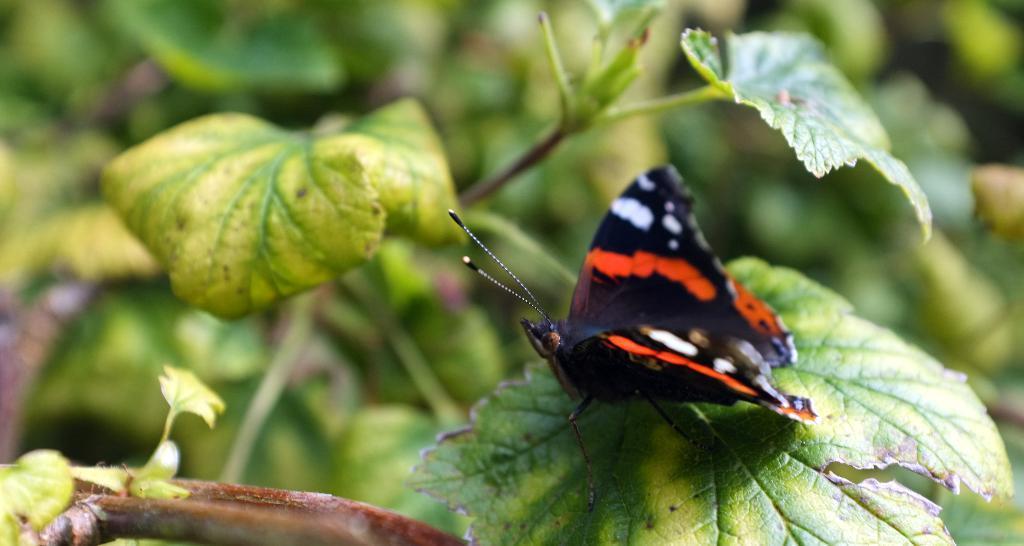How would you summarize this image in a sentence or two? In this picture I can see a butterfly on the leaf and I can see plants in the back. 